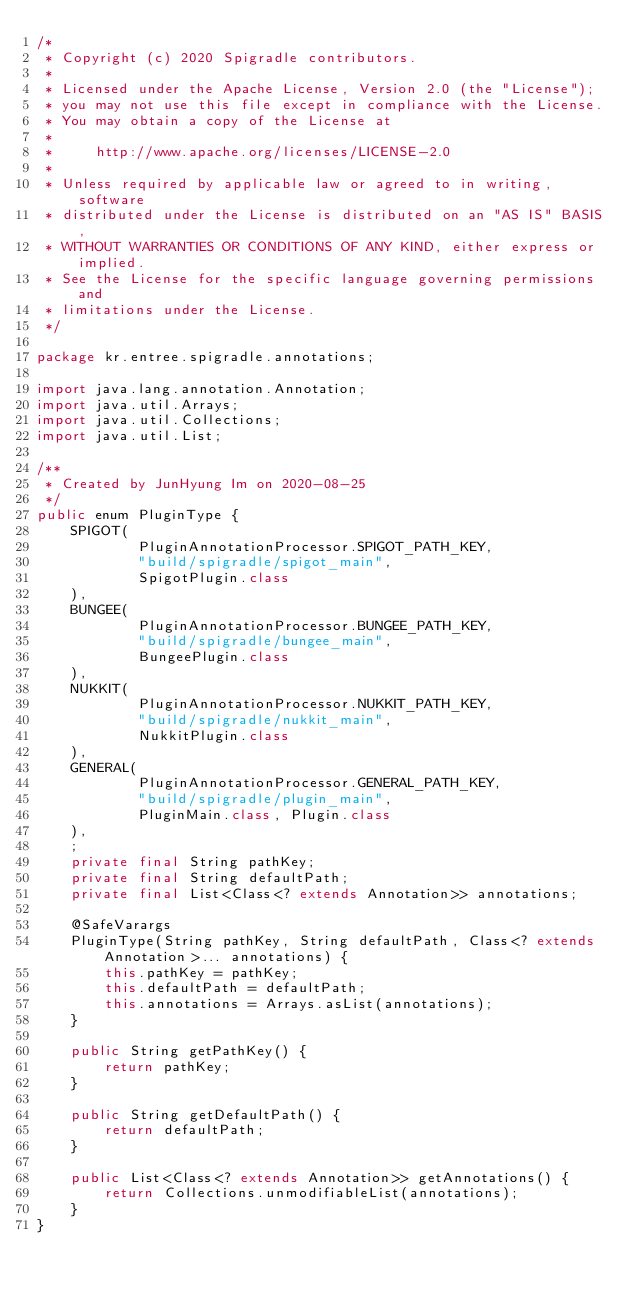Convert code to text. <code><loc_0><loc_0><loc_500><loc_500><_Java_>/*
 * Copyright (c) 2020 Spigradle contributors.
 *
 * Licensed under the Apache License, Version 2.0 (the "License");
 * you may not use this file except in compliance with the License.
 * You may obtain a copy of the License at
 *
 *     http://www.apache.org/licenses/LICENSE-2.0
 *
 * Unless required by applicable law or agreed to in writing, software
 * distributed under the License is distributed on an "AS IS" BASIS,
 * WITHOUT WARRANTIES OR CONDITIONS OF ANY KIND, either express or implied.
 * See the License for the specific language governing permissions and
 * limitations under the License.
 */

package kr.entree.spigradle.annotations;

import java.lang.annotation.Annotation;
import java.util.Arrays;
import java.util.Collections;
import java.util.List;

/**
 * Created by JunHyung Im on 2020-08-25
 */
public enum PluginType {
    SPIGOT(
            PluginAnnotationProcessor.SPIGOT_PATH_KEY,
            "build/spigradle/spigot_main",
            SpigotPlugin.class
    ),
    BUNGEE(
            PluginAnnotationProcessor.BUNGEE_PATH_KEY,
            "build/spigradle/bungee_main",
            BungeePlugin.class
    ),
    NUKKIT(
            PluginAnnotationProcessor.NUKKIT_PATH_KEY,
            "build/spigradle/nukkit_main",
            NukkitPlugin.class
    ),
    GENERAL(
            PluginAnnotationProcessor.GENERAL_PATH_KEY,
            "build/spigradle/plugin_main",
            PluginMain.class, Plugin.class
    ),
    ;
    private final String pathKey;
    private final String defaultPath;
    private final List<Class<? extends Annotation>> annotations;

    @SafeVarargs
    PluginType(String pathKey, String defaultPath, Class<? extends Annotation>... annotations) {
        this.pathKey = pathKey;
        this.defaultPath = defaultPath;
        this.annotations = Arrays.asList(annotations);
    }

    public String getPathKey() {
        return pathKey;
    }

    public String getDefaultPath() {
        return defaultPath;
    }

    public List<Class<? extends Annotation>> getAnnotations() {
        return Collections.unmodifiableList(annotations);
    }
}
</code> 